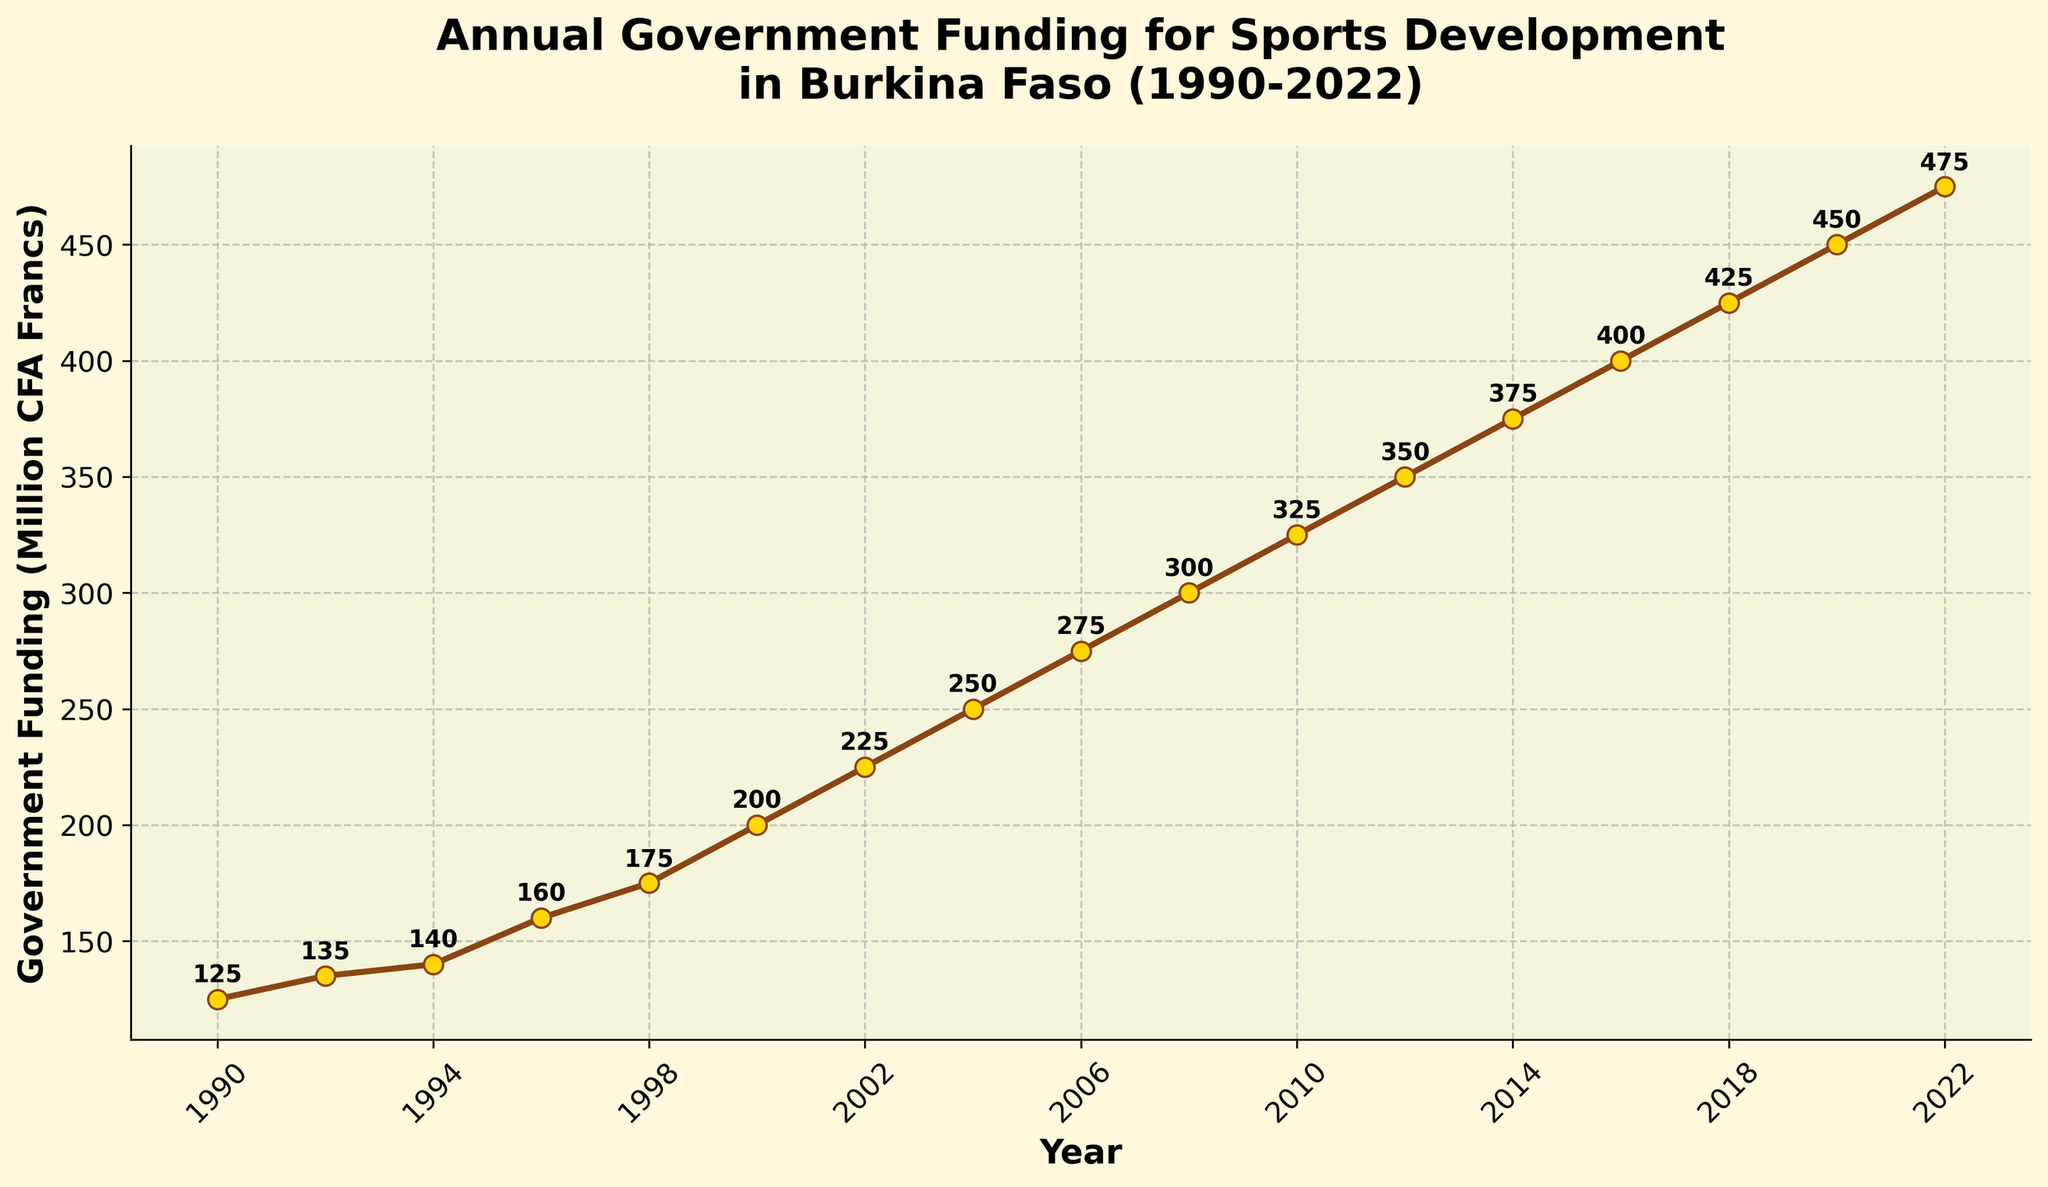What was the government funding for sports development in Burkina Faso in the year 2000? Locate the point for the year 2000 on the x-axis, then find the corresponding value on the y-axis. The funding for the year 2000 was 200 million CFA Francs.
Answer: 200 million CFA Francs Did the funding for sports development increase or decrease between 1996 and 1998? Compare the value for 1996 with the value for 1998. Funding increased from 160 million to 175 million CFA Francs.
Answer: Increase What is the overall trend of government funding for sports development in Burkina Faso from 1990 to 2022? Observe the overall direction of the plotted line from 1990 to 2022. The general trend shows a steady increase in funding over the years.
Answer: Increasing Which year had the highest government funding for sports development, and what was the amount? Identify the highest point on the line plot and note the corresponding year. The highest funding was in 2022, with a value of 475 million CFA Francs.
Answer: 2022, 475 million CFA Francs How much did the funding increase between 2010 and 2014? Subtract the funding value in 2010 from the funding value in 2014. The funding increased from 325 million to 375 million CFA Francs, which is an increase of 50 million.
Answer: 50 million CFA Francs In which decade did the largest increase in government funding for sports development occur? Calculate the funding increase for each decade and compare them. The largest increase occurred between 1990 and 2000, rising from 125 million to 200 million CFA Francs (an increase of 75 million).
Answer: 1990-2000 Calculate the average annual government funding for the period 1990-2000. Sum the funding values for the years 1990, 1992, 1994, 1996, 1998, and 2000, and then divide by the number of years (6). The average funding is (125 + 135 + 140 + 160 + 175 + 200) / 6 = 155 million CFA Francs.
Answer: 155 million CFA Francs Compare the funding in 2018 and 2020. By what percentage did the funding change? First, find the difference between the funding in 2018 and 2020. Then, divide the difference by the 2018 funding and multiply by 100 to get the percentage. The difference is 450 - 425 = 25 million CFA Francs. The percentage change is (25/425) * 100 ≈ 5.88%.
Answer: 5.88% Which year had the least increase in government funding compared to the previous assessed year? Look for the smallest increase between any two consecutive assessed years. The smallest increase was between 1992 and 1994, where the funding increased by only 5 million CFA Francs (135 to 140 million).
Answer: 1992 to 1994 